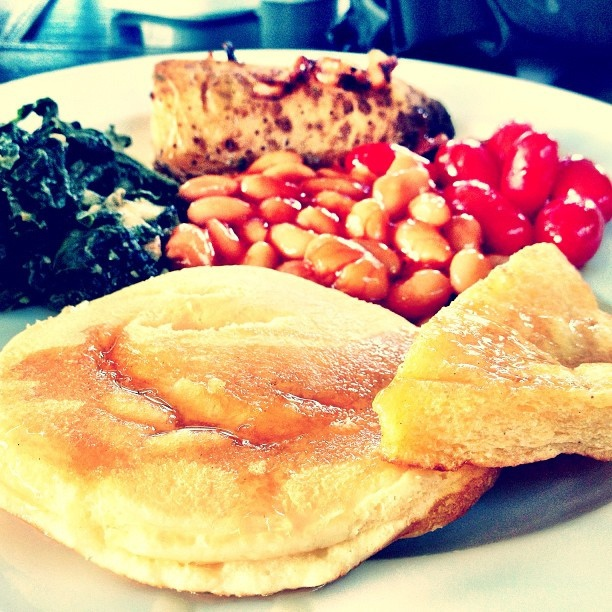Describe the objects in this image and their specific colors. I can see a cake in beige, tan, khaki, salmon, and brown tones in this image. 